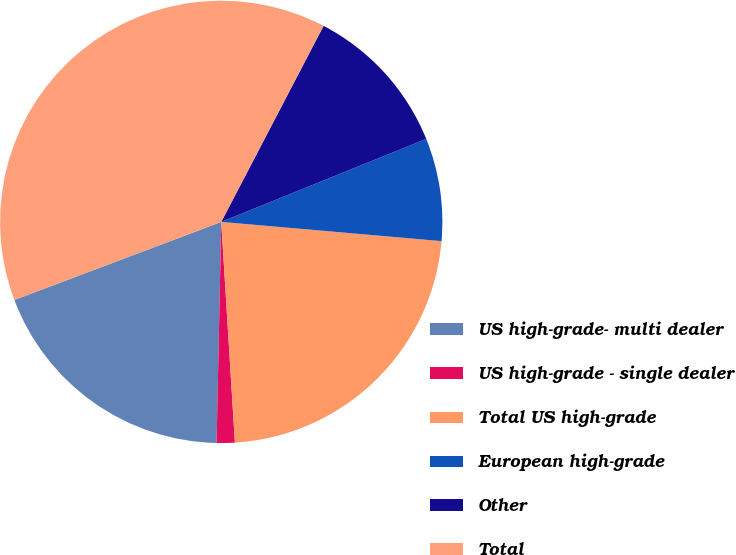Convert chart to OTSL. <chart><loc_0><loc_0><loc_500><loc_500><pie_chart><fcel>US high-grade- multi dealer<fcel>US high-grade - single dealer<fcel>Total US high-grade<fcel>European high-grade<fcel>Other<fcel>Total<nl><fcel>18.92%<fcel>1.32%<fcel>22.63%<fcel>7.51%<fcel>11.22%<fcel>38.4%<nl></chart> 